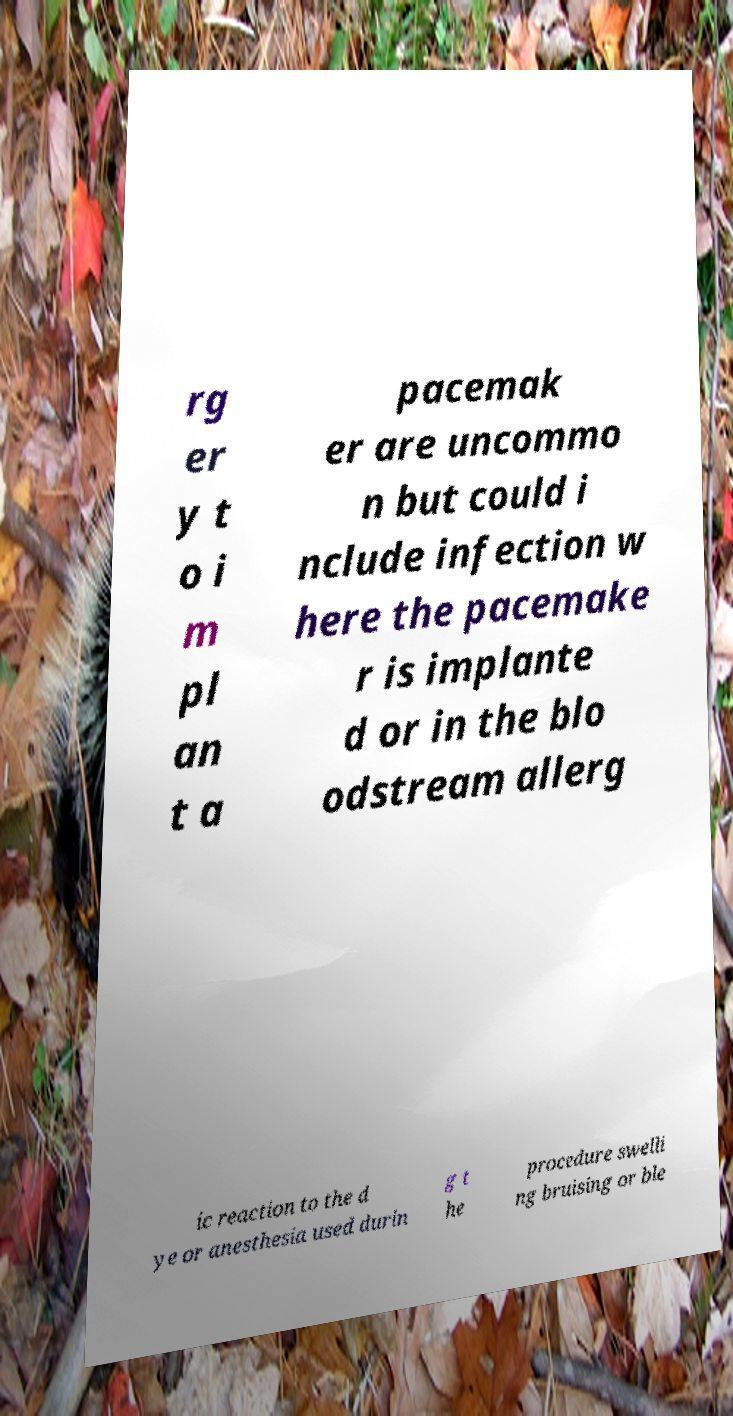What messages or text are displayed in this image? I need them in a readable, typed format. rg er y t o i m pl an t a pacemak er are uncommo n but could i nclude infection w here the pacemake r is implante d or in the blo odstream allerg ic reaction to the d ye or anesthesia used durin g t he procedure swelli ng bruising or ble 